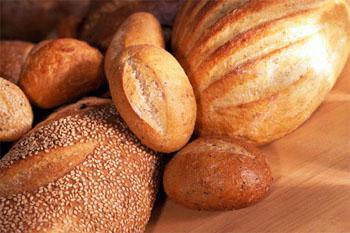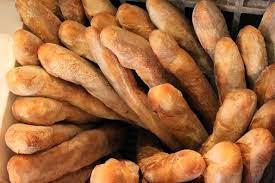The first image is the image on the left, the second image is the image on the right. Assess this claim about the two images: "The left image includes multiple roundish baked loaves with a single slice-mark across the top, and they are not in a container.". Correct or not? Answer yes or no. Yes. 